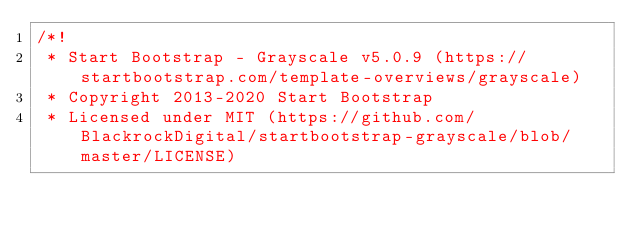Convert code to text. <code><loc_0><loc_0><loc_500><loc_500><_CSS_>/*!
 * Start Bootstrap - Grayscale v5.0.9 (https://startbootstrap.com/template-overviews/grayscale)
 * Copyright 2013-2020 Start Bootstrap
 * Licensed under MIT (https://github.com/BlackrockDigital/startbootstrap-grayscale/blob/master/LICENSE)</code> 